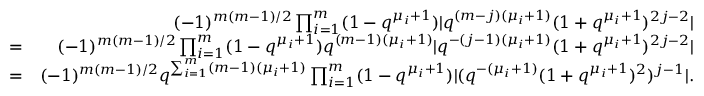Convert formula to latex. <formula><loc_0><loc_0><loc_500><loc_500>\begin{array} { r l r } & { ( - 1 ) ^ { m ( m - 1 ) / 2 } \prod _ { i = 1 } ^ { m } ( 1 - q ^ { \mu _ { i } + 1 } ) | q ^ { ( m - j ) ( \mu _ { i } + 1 ) } ( 1 + q ^ { \mu _ { i } + 1 } ) ^ { 2 j - 2 } | } \\ & { = } & { ( - 1 ) ^ { m ( m - 1 ) / 2 } \prod _ { i = 1 } ^ { m } ( 1 - q ^ { \mu _ { i } + 1 } ) q ^ { ( m - 1 ) ( \mu _ { i } + 1 ) } | q ^ { - ( j - 1 ) ( \mu _ { i } + 1 ) } ( 1 + q ^ { \mu _ { i } + 1 } ) ^ { 2 j - 2 } | } \\ & { = } & { ( - 1 ) ^ { m ( m - 1 ) / 2 } q ^ { \sum _ { i = 1 } ^ { m } ( m - 1 ) ( \mu _ { i } + 1 ) } \prod _ { i = 1 } ^ { m } ( 1 - q ^ { \mu _ { i } + 1 } ) | ( q ^ { - ( \mu _ { i } + 1 ) } ( 1 + q ^ { \mu _ { i } + 1 } ) ^ { 2 } ) ^ { j - 1 } | . } \end{array}</formula> 